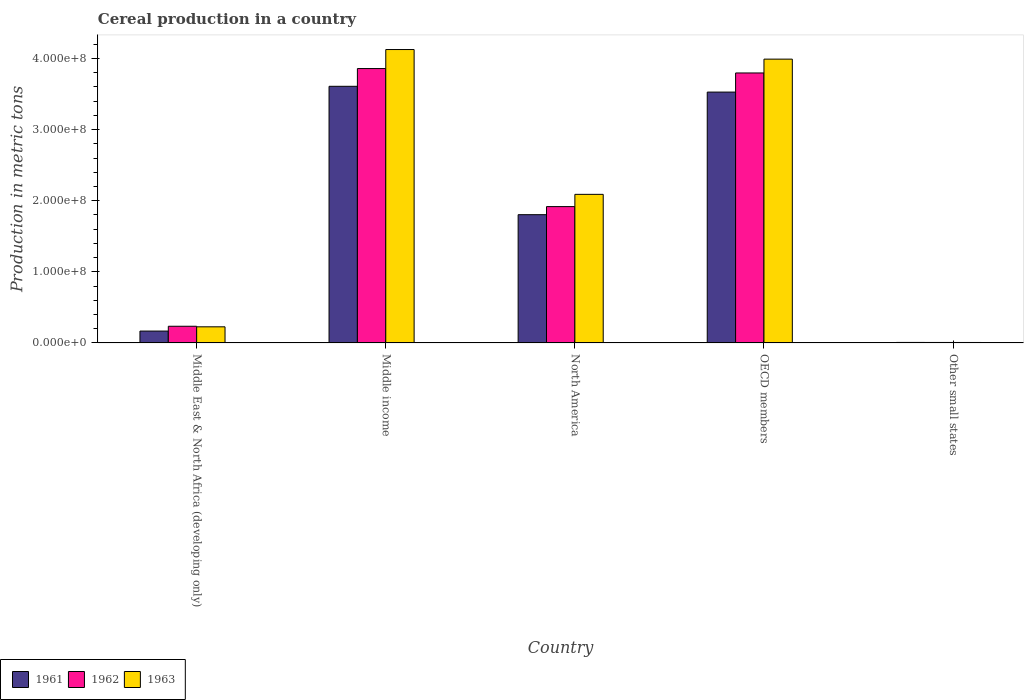How many bars are there on the 3rd tick from the left?
Offer a terse response. 3. What is the label of the 3rd group of bars from the left?
Make the answer very short. North America. In how many cases, is the number of bars for a given country not equal to the number of legend labels?
Ensure brevity in your answer.  0. What is the total cereal production in 1961 in Middle East & North Africa (developing only)?
Give a very brief answer. 1.67e+07. Across all countries, what is the maximum total cereal production in 1963?
Give a very brief answer. 4.13e+08. Across all countries, what is the minimum total cereal production in 1961?
Ensure brevity in your answer.  7.11e+05. In which country was the total cereal production in 1961 minimum?
Give a very brief answer. Other small states. What is the total total cereal production in 1961 in the graph?
Offer a terse response. 9.11e+08. What is the difference between the total cereal production in 1963 in Middle income and that in OECD members?
Your answer should be very brief. 1.35e+07. What is the difference between the total cereal production in 1963 in OECD members and the total cereal production in 1961 in Middle East & North Africa (developing only)?
Provide a succinct answer. 3.82e+08. What is the average total cereal production in 1961 per country?
Keep it short and to the point. 1.82e+08. What is the difference between the total cereal production of/in 1963 and total cereal production of/in 1961 in Middle income?
Your answer should be very brief. 5.17e+07. What is the ratio of the total cereal production in 1961 in North America to that in Other small states?
Your answer should be compact. 253.7. Is the difference between the total cereal production in 1963 in Middle income and North America greater than the difference between the total cereal production in 1961 in Middle income and North America?
Make the answer very short. Yes. What is the difference between the highest and the second highest total cereal production in 1961?
Offer a very short reply. 1.72e+08. What is the difference between the highest and the lowest total cereal production in 1963?
Keep it short and to the point. 4.12e+08. In how many countries, is the total cereal production in 1963 greater than the average total cereal production in 1963 taken over all countries?
Provide a succinct answer. 3. Is the sum of the total cereal production in 1962 in Middle East & North Africa (developing only) and OECD members greater than the maximum total cereal production in 1961 across all countries?
Provide a succinct answer. Yes. What does the 1st bar from the right in Other small states represents?
Keep it short and to the point. 1963. How many bars are there?
Make the answer very short. 15. How many countries are there in the graph?
Your answer should be very brief. 5. Are the values on the major ticks of Y-axis written in scientific E-notation?
Your answer should be compact. Yes. Does the graph contain any zero values?
Your answer should be very brief. No. Does the graph contain grids?
Give a very brief answer. No. How many legend labels are there?
Offer a terse response. 3. How are the legend labels stacked?
Make the answer very short. Horizontal. What is the title of the graph?
Make the answer very short. Cereal production in a country. Does "2009" appear as one of the legend labels in the graph?
Offer a terse response. No. What is the label or title of the Y-axis?
Offer a terse response. Production in metric tons. What is the Production in metric tons in 1961 in Middle East & North Africa (developing only)?
Offer a very short reply. 1.67e+07. What is the Production in metric tons in 1962 in Middle East & North Africa (developing only)?
Keep it short and to the point. 2.35e+07. What is the Production in metric tons in 1963 in Middle East & North Africa (developing only)?
Your response must be concise. 2.27e+07. What is the Production in metric tons of 1961 in Middle income?
Your answer should be compact. 3.61e+08. What is the Production in metric tons of 1962 in Middle income?
Provide a succinct answer. 3.86e+08. What is the Production in metric tons of 1963 in Middle income?
Provide a short and direct response. 4.13e+08. What is the Production in metric tons in 1961 in North America?
Your response must be concise. 1.80e+08. What is the Production in metric tons in 1962 in North America?
Your answer should be very brief. 1.92e+08. What is the Production in metric tons of 1963 in North America?
Provide a succinct answer. 2.09e+08. What is the Production in metric tons in 1961 in OECD members?
Ensure brevity in your answer.  3.53e+08. What is the Production in metric tons of 1962 in OECD members?
Offer a very short reply. 3.80e+08. What is the Production in metric tons in 1963 in OECD members?
Your answer should be very brief. 3.99e+08. What is the Production in metric tons in 1961 in Other small states?
Provide a succinct answer. 7.11e+05. What is the Production in metric tons of 1962 in Other small states?
Your response must be concise. 6.75e+05. What is the Production in metric tons of 1963 in Other small states?
Your answer should be very brief. 6.58e+05. Across all countries, what is the maximum Production in metric tons in 1961?
Keep it short and to the point. 3.61e+08. Across all countries, what is the maximum Production in metric tons in 1962?
Offer a terse response. 3.86e+08. Across all countries, what is the maximum Production in metric tons in 1963?
Keep it short and to the point. 4.13e+08. Across all countries, what is the minimum Production in metric tons in 1961?
Give a very brief answer. 7.11e+05. Across all countries, what is the minimum Production in metric tons of 1962?
Offer a very short reply. 6.75e+05. Across all countries, what is the minimum Production in metric tons of 1963?
Provide a short and direct response. 6.58e+05. What is the total Production in metric tons of 1961 in the graph?
Ensure brevity in your answer.  9.11e+08. What is the total Production in metric tons of 1962 in the graph?
Offer a very short reply. 9.81e+08. What is the total Production in metric tons in 1963 in the graph?
Ensure brevity in your answer.  1.04e+09. What is the difference between the Production in metric tons of 1961 in Middle East & North Africa (developing only) and that in Middle income?
Your response must be concise. -3.44e+08. What is the difference between the Production in metric tons of 1962 in Middle East & North Africa (developing only) and that in Middle income?
Ensure brevity in your answer.  -3.62e+08. What is the difference between the Production in metric tons in 1963 in Middle East & North Africa (developing only) and that in Middle income?
Provide a short and direct response. -3.90e+08. What is the difference between the Production in metric tons of 1961 in Middle East & North Africa (developing only) and that in North America?
Your answer should be compact. -1.64e+08. What is the difference between the Production in metric tons in 1962 in Middle East & North Africa (developing only) and that in North America?
Make the answer very short. -1.68e+08. What is the difference between the Production in metric tons in 1963 in Middle East & North Africa (developing only) and that in North America?
Your response must be concise. -1.86e+08. What is the difference between the Production in metric tons of 1961 in Middle East & North Africa (developing only) and that in OECD members?
Offer a very short reply. -3.36e+08. What is the difference between the Production in metric tons in 1962 in Middle East & North Africa (developing only) and that in OECD members?
Provide a short and direct response. -3.56e+08. What is the difference between the Production in metric tons in 1963 in Middle East & North Africa (developing only) and that in OECD members?
Ensure brevity in your answer.  -3.76e+08. What is the difference between the Production in metric tons in 1961 in Middle East & North Africa (developing only) and that in Other small states?
Keep it short and to the point. 1.60e+07. What is the difference between the Production in metric tons in 1962 in Middle East & North Africa (developing only) and that in Other small states?
Offer a very short reply. 2.28e+07. What is the difference between the Production in metric tons in 1963 in Middle East & North Africa (developing only) and that in Other small states?
Offer a terse response. 2.20e+07. What is the difference between the Production in metric tons in 1961 in Middle income and that in North America?
Make the answer very short. 1.81e+08. What is the difference between the Production in metric tons of 1962 in Middle income and that in North America?
Provide a succinct answer. 1.94e+08. What is the difference between the Production in metric tons in 1963 in Middle income and that in North America?
Offer a very short reply. 2.04e+08. What is the difference between the Production in metric tons of 1961 in Middle income and that in OECD members?
Your response must be concise. 8.13e+06. What is the difference between the Production in metric tons in 1962 in Middle income and that in OECD members?
Make the answer very short. 6.21e+06. What is the difference between the Production in metric tons in 1963 in Middle income and that in OECD members?
Your response must be concise. 1.35e+07. What is the difference between the Production in metric tons in 1961 in Middle income and that in Other small states?
Your answer should be very brief. 3.60e+08. What is the difference between the Production in metric tons of 1962 in Middle income and that in Other small states?
Your answer should be very brief. 3.85e+08. What is the difference between the Production in metric tons in 1963 in Middle income and that in Other small states?
Ensure brevity in your answer.  4.12e+08. What is the difference between the Production in metric tons in 1961 in North America and that in OECD members?
Keep it short and to the point. -1.72e+08. What is the difference between the Production in metric tons in 1962 in North America and that in OECD members?
Offer a terse response. -1.88e+08. What is the difference between the Production in metric tons of 1963 in North America and that in OECD members?
Keep it short and to the point. -1.90e+08. What is the difference between the Production in metric tons of 1961 in North America and that in Other small states?
Offer a very short reply. 1.80e+08. What is the difference between the Production in metric tons of 1962 in North America and that in Other small states?
Keep it short and to the point. 1.91e+08. What is the difference between the Production in metric tons of 1963 in North America and that in Other small states?
Give a very brief answer. 2.08e+08. What is the difference between the Production in metric tons of 1961 in OECD members and that in Other small states?
Your response must be concise. 3.52e+08. What is the difference between the Production in metric tons of 1962 in OECD members and that in Other small states?
Your answer should be compact. 3.79e+08. What is the difference between the Production in metric tons of 1963 in OECD members and that in Other small states?
Keep it short and to the point. 3.98e+08. What is the difference between the Production in metric tons in 1961 in Middle East & North Africa (developing only) and the Production in metric tons in 1962 in Middle income?
Ensure brevity in your answer.  -3.69e+08. What is the difference between the Production in metric tons in 1961 in Middle East & North Africa (developing only) and the Production in metric tons in 1963 in Middle income?
Ensure brevity in your answer.  -3.96e+08. What is the difference between the Production in metric tons in 1962 in Middle East & North Africa (developing only) and the Production in metric tons in 1963 in Middle income?
Give a very brief answer. -3.89e+08. What is the difference between the Production in metric tons in 1961 in Middle East & North Africa (developing only) and the Production in metric tons in 1962 in North America?
Your answer should be compact. -1.75e+08. What is the difference between the Production in metric tons of 1961 in Middle East & North Africa (developing only) and the Production in metric tons of 1963 in North America?
Your answer should be compact. -1.92e+08. What is the difference between the Production in metric tons in 1962 in Middle East & North Africa (developing only) and the Production in metric tons in 1963 in North America?
Give a very brief answer. -1.85e+08. What is the difference between the Production in metric tons in 1961 in Middle East & North Africa (developing only) and the Production in metric tons in 1962 in OECD members?
Offer a terse response. -3.63e+08. What is the difference between the Production in metric tons in 1961 in Middle East & North Africa (developing only) and the Production in metric tons in 1963 in OECD members?
Your answer should be compact. -3.82e+08. What is the difference between the Production in metric tons in 1962 in Middle East & North Africa (developing only) and the Production in metric tons in 1963 in OECD members?
Your answer should be compact. -3.76e+08. What is the difference between the Production in metric tons in 1961 in Middle East & North Africa (developing only) and the Production in metric tons in 1962 in Other small states?
Your response must be concise. 1.60e+07. What is the difference between the Production in metric tons in 1961 in Middle East & North Africa (developing only) and the Production in metric tons in 1963 in Other small states?
Ensure brevity in your answer.  1.60e+07. What is the difference between the Production in metric tons of 1962 in Middle East & North Africa (developing only) and the Production in metric tons of 1963 in Other small states?
Keep it short and to the point. 2.28e+07. What is the difference between the Production in metric tons in 1961 in Middle income and the Production in metric tons in 1962 in North America?
Provide a succinct answer. 1.69e+08. What is the difference between the Production in metric tons of 1961 in Middle income and the Production in metric tons of 1963 in North America?
Keep it short and to the point. 1.52e+08. What is the difference between the Production in metric tons in 1962 in Middle income and the Production in metric tons in 1963 in North America?
Your answer should be compact. 1.77e+08. What is the difference between the Production in metric tons in 1961 in Middle income and the Production in metric tons in 1962 in OECD members?
Provide a succinct answer. -1.88e+07. What is the difference between the Production in metric tons of 1961 in Middle income and the Production in metric tons of 1963 in OECD members?
Provide a short and direct response. -3.82e+07. What is the difference between the Production in metric tons of 1962 in Middle income and the Production in metric tons of 1963 in OECD members?
Give a very brief answer. -1.32e+07. What is the difference between the Production in metric tons in 1961 in Middle income and the Production in metric tons in 1962 in Other small states?
Provide a short and direct response. 3.60e+08. What is the difference between the Production in metric tons in 1961 in Middle income and the Production in metric tons in 1963 in Other small states?
Your answer should be very brief. 3.60e+08. What is the difference between the Production in metric tons in 1962 in Middle income and the Production in metric tons in 1963 in Other small states?
Give a very brief answer. 3.85e+08. What is the difference between the Production in metric tons in 1961 in North America and the Production in metric tons in 1962 in OECD members?
Make the answer very short. -1.99e+08. What is the difference between the Production in metric tons in 1961 in North America and the Production in metric tons in 1963 in OECD members?
Offer a terse response. -2.19e+08. What is the difference between the Production in metric tons of 1962 in North America and the Production in metric tons of 1963 in OECD members?
Keep it short and to the point. -2.07e+08. What is the difference between the Production in metric tons of 1961 in North America and the Production in metric tons of 1962 in Other small states?
Your answer should be compact. 1.80e+08. What is the difference between the Production in metric tons of 1961 in North America and the Production in metric tons of 1963 in Other small states?
Offer a terse response. 1.80e+08. What is the difference between the Production in metric tons in 1962 in North America and the Production in metric tons in 1963 in Other small states?
Provide a succinct answer. 1.91e+08. What is the difference between the Production in metric tons in 1961 in OECD members and the Production in metric tons in 1962 in Other small states?
Offer a terse response. 3.52e+08. What is the difference between the Production in metric tons in 1961 in OECD members and the Production in metric tons in 1963 in Other small states?
Ensure brevity in your answer.  3.52e+08. What is the difference between the Production in metric tons in 1962 in OECD members and the Production in metric tons in 1963 in Other small states?
Your response must be concise. 3.79e+08. What is the average Production in metric tons in 1961 per country?
Give a very brief answer. 1.82e+08. What is the average Production in metric tons of 1962 per country?
Keep it short and to the point. 1.96e+08. What is the average Production in metric tons in 1963 per country?
Provide a succinct answer. 2.09e+08. What is the difference between the Production in metric tons in 1961 and Production in metric tons in 1962 in Middle East & North Africa (developing only)?
Make the answer very short. -6.77e+06. What is the difference between the Production in metric tons of 1961 and Production in metric tons of 1963 in Middle East & North Africa (developing only)?
Your answer should be very brief. -5.99e+06. What is the difference between the Production in metric tons in 1962 and Production in metric tons in 1963 in Middle East & North Africa (developing only)?
Offer a terse response. 7.80e+05. What is the difference between the Production in metric tons of 1961 and Production in metric tons of 1962 in Middle income?
Provide a succinct answer. -2.50e+07. What is the difference between the Production in metric tons in 1961 and Production in metric tons in 1963 in Middle income?
Ensure brevity in your answer.  -5.17e+07. What is the difference between the Production in metric tons in 1962 and Production in metric tons in 1963 in Middle income?
Give a very brief answer. -2.67e+07. What is the difference between the Production in metric tons in 1961 and Production in metric tons in 1962 in North America?
Make the answer very short. -1.14e+07. What is the difference between the Production in metric tons of 1961 and Production in metric tons of 1963 in North America?
Your answer should be very brief. -2.86e+07. What is the difference between the Production in metric tons in 1962 and Production in metric tons in 1963 in North America?
Provide a short and direct response. -1.72e+07. What is the difference between the Production in metric tons in 1961 and Production in metric tons in 1962 in OECD members?
Provide a short and direct response. -2.69e+07. What is the difference between the Production in metric tons in 1961 and Production in metric tons in 1963 in OECD members?
Make the answer very short. -4.63e+07. What is the difference between the Production in metric tons of 1962 and Production in metric tons of 1963 in OECD members?
Provide a succinct answer. -1.94e+07. What is the difference between the Production in metric tons in 1961 and Production in metric tons in 1962 in Other small states?
Give a very brief answer. 3.58e+04. What is the difference between the Production in metric tons in 1961 and Production in metric tons in 1963 in Other small states?
Your answer should be very brief. 5.26e+04. What is the difference between the Production in metric tons of 1962 and Production in metric tons of 1963 in Other small states?
Give a very brief answer. 1.67e+04. What is the ratio of the Production in metric tons of 1961 in Middle East & North Africa (developing only) to that in Middle income?
Keep it short and to the point. 0.05. What is the ratio of the Production in metric tons of 1962 in Middle East & North Africa (developing only) to that in Middle income?
Offer a very short reply. 0.06. What is the ratio of the Production in metric tons of 1963 in Middle East & North Africa (developing only) to that in Middle income?
Your response must be concise. 0.06. What is the ratio of the Production in metric tons of 1961 in Middle East & North Africa (developing only) to that in North America?
Offer a very short reply. 0.09. What is the ratio of the Production in metric tons in 1962 in Middle East & North Africa (developing only) to that in North America?
Offer a terse response. 0.12. What is the ratio of the Production in metric tons of 1963 in Middle East & North Africa (developing only) to that in North America?
Your answer should be very brief. 0.11. What is the ratio of the Production in metric tons of 1961 in Middle East & North Africa (developing only) to that in OECD members?
Provide a succinct answer. 0.05. What is the ratio of the Production in metric tons in 1962 in Middle East & North Africa (developing only) to that in OECD members?
Make the answer very short. 0.06. What is the ratio of the Production in metric tons of 1963 in Middle East & North Africa (developing only) to that in OECD members?
Ensure brevity in your answer.  0.06. What is the ratio of the Production in metric tons of 1961 in Middle East & North Africa (developing only) to that in Other small states?
Provide a succinct answer. 23.47. What is the ratio of the Production in metric tons in 1962 in Middle East & North Africa (developing only) to that in Other small states?
Keep it short and to the point. 34.75. What is the ratio of the Production in metric tons in 1963 in Middle East & North Africa (developing only) to that in Other small states?
Provide a short and direct response. 34.45. What is the ratio of the Production in metric tons of 1961 in Middle income to that in North America?
Provide a succinct answer. 2. What is the ratio of the Production in metric tons in 1962 in Middle income to that in North America?
Provide a succinct answer. 2.01. What is the ratio of the Production in metric tons of 1963 in Middle income to that in North America?
Your answer should be very brief. 1.97. What is the ratio of the Production in metric tons in 1961 in Middle income to that in OECD members?
Offer a terse response. 1.02. What is the ratio of the Production in metric tons in 1962 in Middle income to that in OECD members?
Make the answer very short. 1.02. What is the ratio of the Production in metric tons in 1963 in Middle income to that in OECD members?
Your answer should be very brief. 1.03. What is the ratio of the Production in metric tons of 1961 in Middle income to that in Other small states?
Ensure brevity in your answer.  507.62. What is the ratio of the Production in metric tons in 1962 in Middle income to that in Other small states?
Ensure brevity in your answer.  571.56. What is the ratio of the Production in metric tons of 1963 in Middle income to that in Other small states?
Make the answer very short. 626.66. What is the ratio of the Production in metric tons of 1961 in North America to that in OECD members?
Your response must be concise. 0.51. What is the ratio of the Production in metric tons in 1962 in North America to that in OECD members?
Provide a short and direct response. 0.51. What is the ratio of the Production in metric tons of 1963 in North America to that in OECD members?
Make the answer very short. 0.52. What is the ratio of the Production in metric tons of 1961 in North America to that in Other small states?
Your answer should be very brief. 253.7. What is the ratio of the Production in metric tons of 1962 in North America to that in Other small states?
Provide a succinct answer. 284.01. What is the ratio of the Production in metric tons in 1963 in North America to that in Other small states?
Your answer should be compact. 317.37. What is the ratio of the Production in metric tons in 1961 in OECD members to that in Other small states?
Offer a very short reply. 496.18. What is the ratio of the Production in metric tons in 1962 in OECD members to that in Other small states?
Your response must be concise. 562.36. What is the ratio of the Production in metric tons in 1963 in OECD members to that in Other small states?
Offer a terse response. 606.18. What is the difference between the highest and the second highest Production in metric tons of 1961?
Provide a short and direct response. 8.13e+06. What is the difference between the highest and the second highest Production in metric tons of 1962?
Keep it short and to the point. 6.21e+06. What is the difference between the highest and the second highest Production in metric tons in 1963?
Provide a short and direct response. 1.35e+07. What is the difference between the highest and the lowest Production in metric tons of 1961?
Give a very brief answer. 3.60e+08. What is the difference between the highest and the lowest Production in metric tons of 1962?
Offer a terse response. 3.85e+08. What is the difference between the highest and the lowest Production in metric tons in 1963?
Provide a short and direct response. 4.12e+08. 